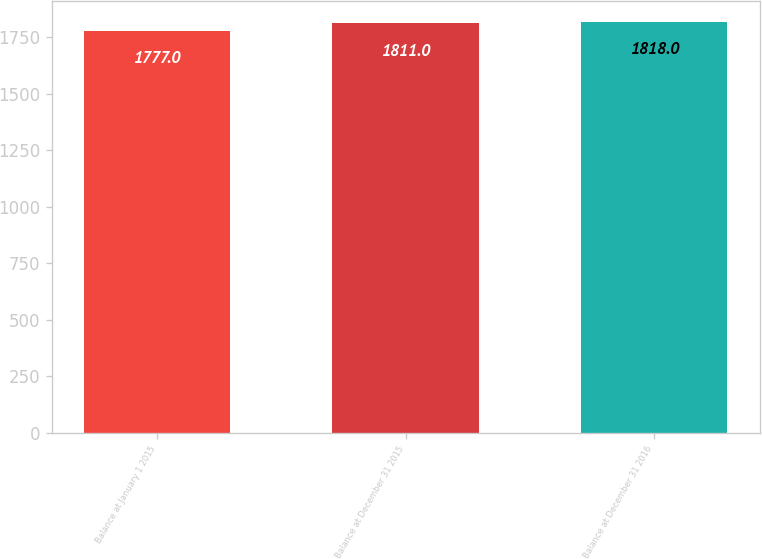Convert chart to OTSL. <chart><loc_0><loc_0><loc_500><loc_500><bar_chart><fcel>Balance at January 1 2015<fcel>Balance at December 31 2015<fcel>Balance at December 31 2016<nl><fcel>1777<fcel>1811<fcel>1818<nl></chart> 